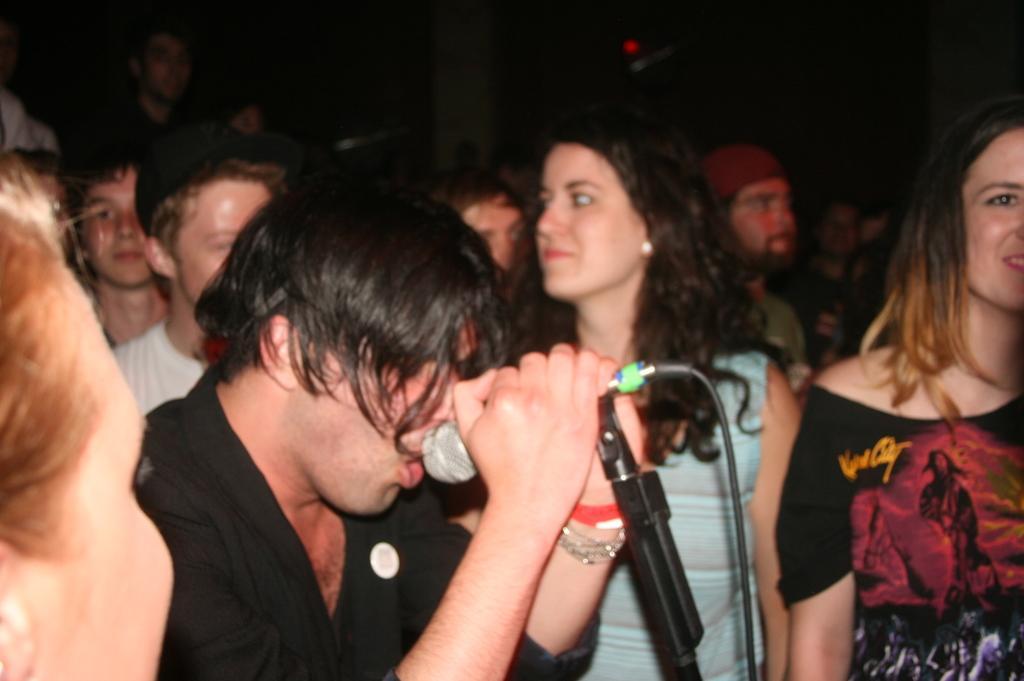Could you give a brief overview of what you see in this image? In the image we can see there are many people, both girls and boys. This is a microphone. This is a cable wire. 